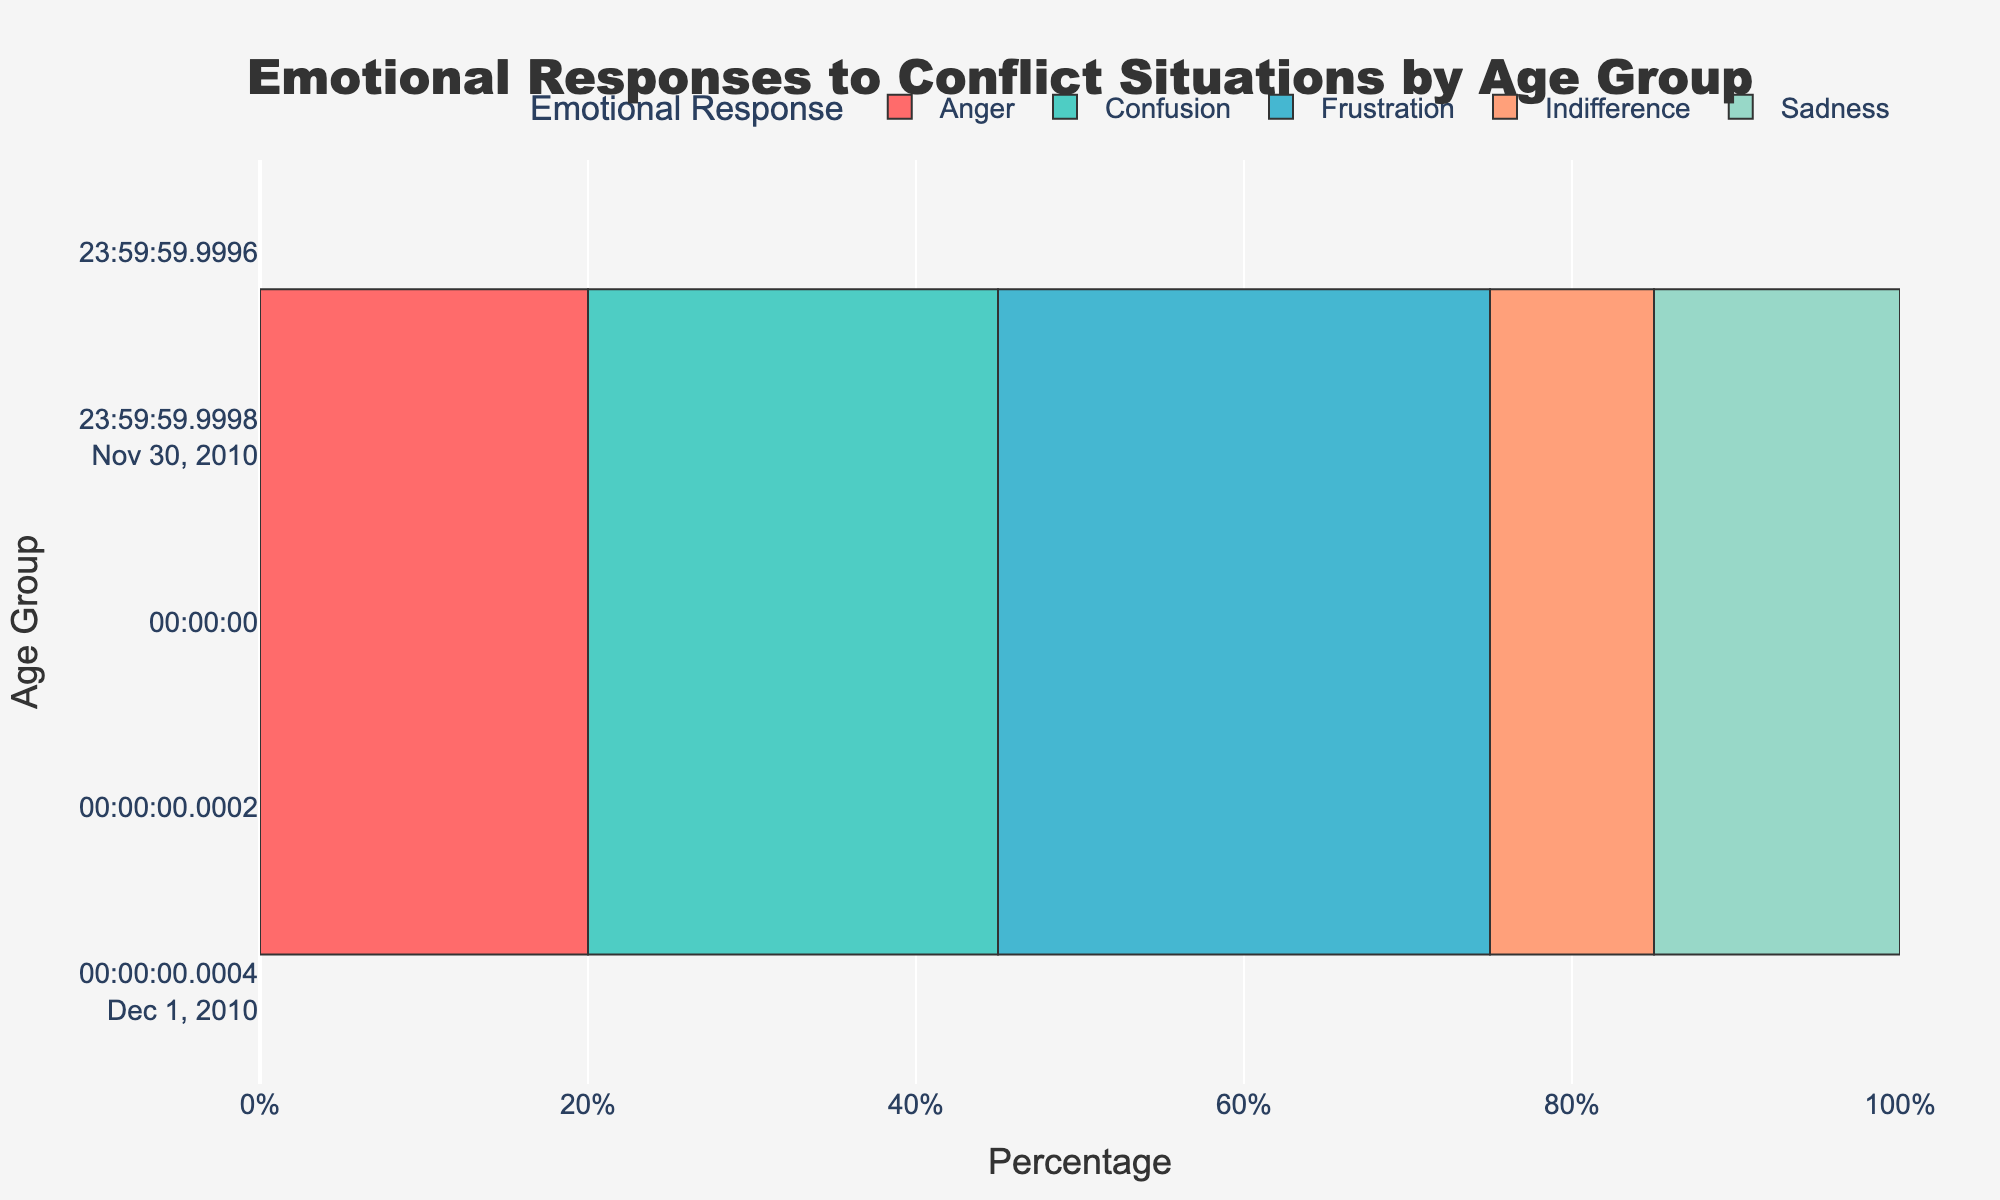What is the most common emotional response for the 16-18 age group? Look at the bar lengths for the 16-18 age group and identify which emotional response has the longest bar. The Anger bar is the longest, indicating it is the most common.
Answer: Anger Which age group shows the highest percentage of Indifference? Compare the lengths of the Indifference bars across all age groups. The 22-24 age group has the longest Indifference bar at 25%.
Answer: 22-24 How does the percentage of Anger in the 19-21 age group compare to the 10-12 age group? Look at the lengths of the Anger bars for both age groups. The bar for the 10-12 group shows 20%, and the 19-21 group shows 15%. Therefore, the 19-21 has a lower percentage of Anger compared to the 10-12 group.
Answer: 19-21 is lower Which emotional response has the second-highest percentage in the 13-15 age group? Identify the second-longest bar for the 13-15 age group. The longest bar is Frustration at 30%, and the second-longest bar is Anger at 25%.
Answer: Anger What is the combined percentage of Sadness and Frustration in the 22-24 age group? Look at the lengths of the Sadness and Frustration bars for the 22-24 age group. The Sadness bar is 15%, and the Frustration bar is 15%. Add these values to get the combined percentage. 15% + 15% = 30%
Answer: 30% Which age group has the least percentage of Confusion? Compare the lengths of the Confusion bars across all age groups. The shortest bar belongs to the 22-24 age group, where the percentage of Confusion is 5%.
Answer: 22-24 Between the 10-12 and 22-24 age groups, which has a higher Frustration percentage, and by how much? Compare the Frustration bars for these age groups. The 10-12 age group has 30% Frustration, and the 22-24 age group has 15%. Subtract the smaller percentage from the larger percentage to find the difference. 30% - 15% = 15%
Answer: 10-12 by 15% In which age group are Anger and Indifference percentages equal, and what are those percentages? Look for age groups where the lengths of the bars for Anger and Indifference are the same. The 22-24 age group has both Anger and Indifference at 10%.
Answer: 22-24, 10% Which age group reports the highest percentage of Sadness, and what is that percentage? Look for the longest Sadness bar across all age groups. The longest bar is in the 16-18 age group, showing Sadness at 25%.
Answer: 16-18, 25% 